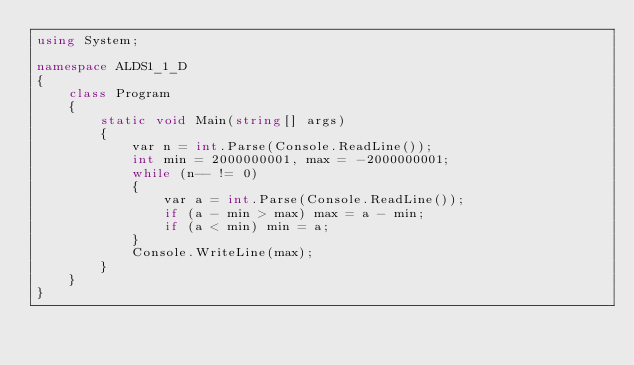<code> <loc_0><loc_0><loc_500><loc_500><_C#_>using System;

namespace ALDS1_1_D
{
    class Program
    {
        static void Main(string[] args)
        {
            var n = int.Parse(Console.ReadLine());
            int min = 2000000001, max = -2000000001;
            while (n-- != 0)
            {
                var a = int.Parse(Console.ReadLine());
                if (a - min > max) max = a - min;
                if (a < min) min = a;
            }
            Console.WriteLine(max);
        }
    }
}</code> 